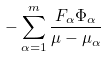<formula> <loc_0><loc_0><loc_500><loc_500>- \sum ^ { m } _ { \alpha = 1 } \frac { F _ { \alpha } \Phi _ { \alpha } } { \mu - \mu _ { \alpha } }</formula> 